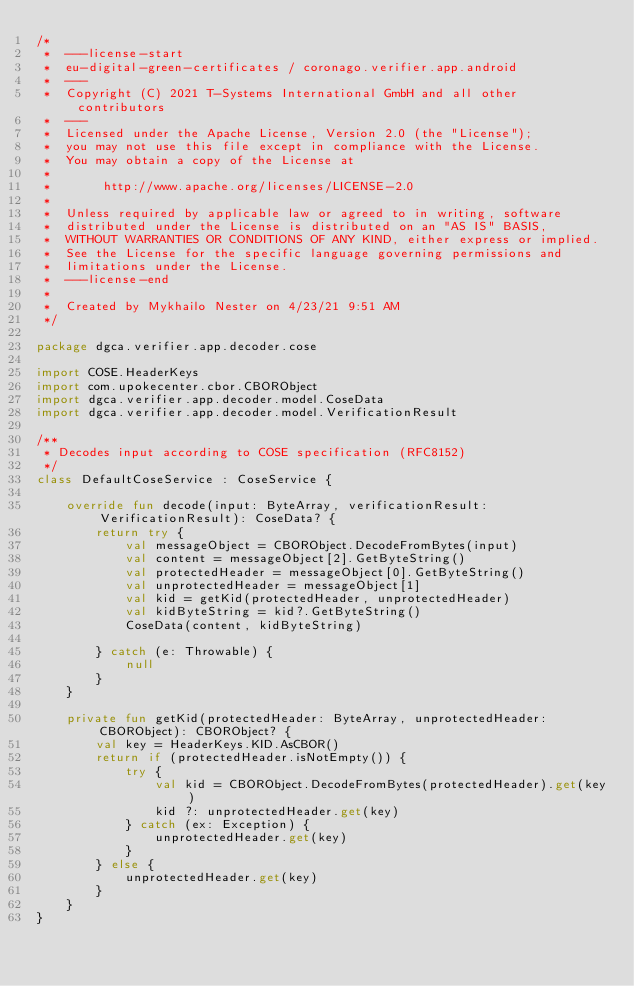Convert code to text. <code><loc_0><loc_0><loc_500><loc_500><_Kotlin_>/*
 *  ---license-start
 *  eu-digital-green-certificates / coronago.verifier.app.android
 *  ---
 *  Copyright (C) 2021 T-Systems International GmbH and all other contributors
 *  ---
 *  Licensed under the Apache License, Version 2.0 (the "License");
 *  you may not use this file except in compliance with the License.
 *  You may obtain a copy of the License at
 *
 *       http://www.apache.org/licenses/LICENSE-2.0
 *
 *  Unless required by applicable law or agreed to in writing, software
 *  distributed under the License is distributed on an "AS IS" BASIS,
 *  WITHOUT WARRANTIES OR CONDITIONS OF ANY KIND, either express or implied.
 *  See the License for the specific language governing permissions and
 *  limitations under the License.
 *  ---license-end
 *
 *  Created by Mykhailo Nester on 4/23/21 9:51 AM
 */

package dgca.verifier.app.decoder.cose

import COSE.HeaderKeys
import com.upokecenter.cbor.CBORObject
import dgca.verifier.app.decoder.model.CoseData
import dgca.verifier.app.decoder.model.VerificationResult

/**
 * Decodes input according to COSE specification (RFC8152)
 */
class DefaultCoseService : CoseService {

    override fun decode(input: ByteArray, verificationResult: VerificationResult): CoseData? {
        return try {
            val messageObject = CBORObject.DecodeFromBytes(input)
            val content = messageObject[2].GetByteString()
            val protectedHeader = messageObject[0].GetByteString()
            val unprotectedHeader = messageObject[1]
            val kid = getKid(protectedHeader, unprotectedHeader)
            val kidByteString = kid?.GetByteString()
            CoseData(content, kidByteString)

        } catch (e: Throwable) {
            null
        }
    }

    private fun getKid(protectedHeader: ByteArray, unprotectedHeader: CBORObject): CBORObject? {
        val key = HeaderKeys.KID.AsCBOR()
        return if (protectedHeader.isNotEmpty()) {
            try {
                val kid = CBORObject.DecodeFromBytes(protectedHeader).get(key)
                kid ?: unprotectedHeader.get(key)
            } catch (ex: Exception) {
                unprotectedHeader.get(key)
            }
        } else {
            unprotectedHeader.get(key)
        }
    }
}</code> 